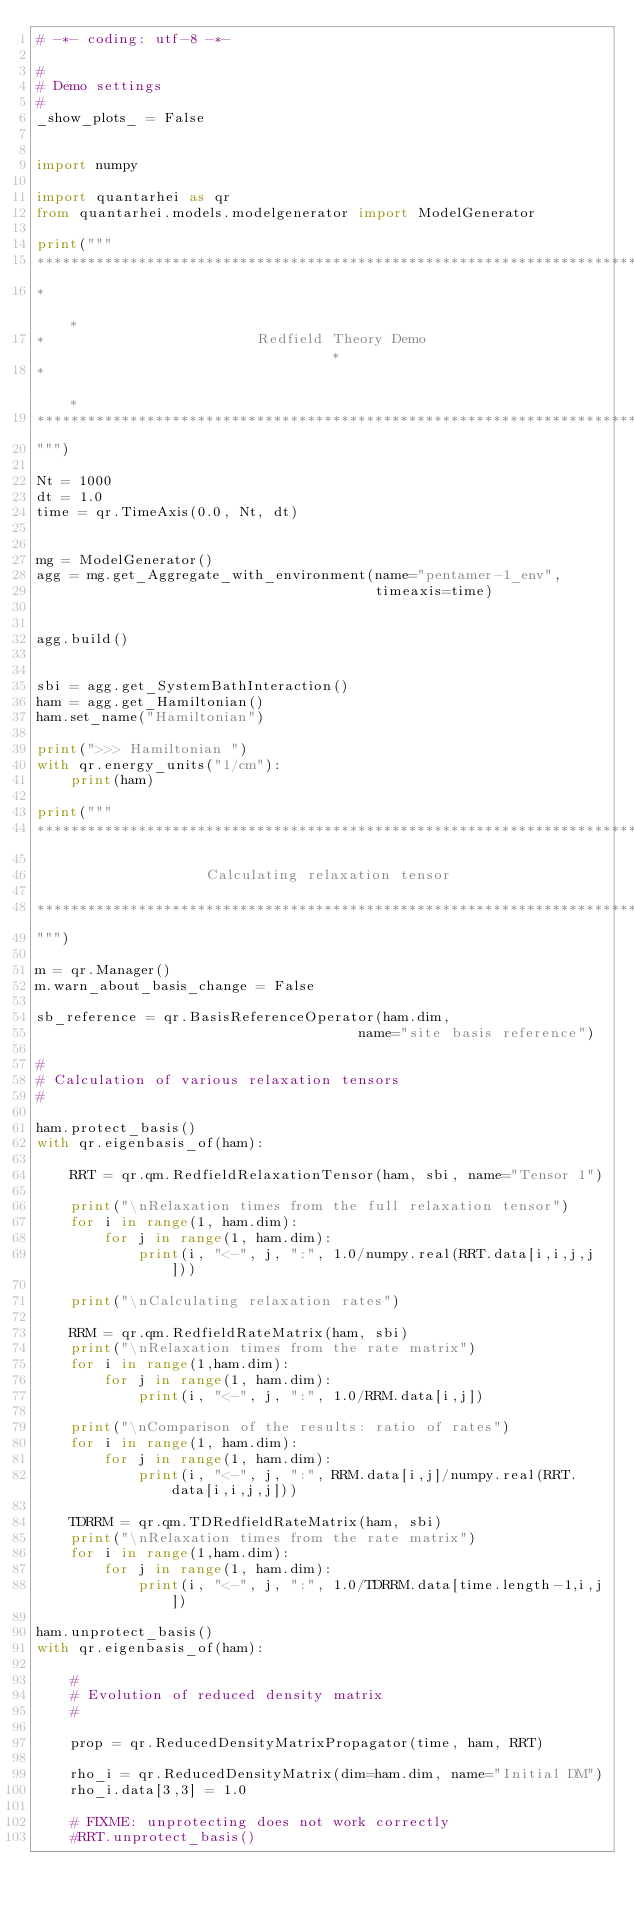Convert code to text. <code><loc_0><loc_0><loc_500><loc_500><_Python_># -*- coding: utf-8 -*-

#
# Demo settings
#
_show_plots_ = False


import numpy

import quantarhei as qr
from quantarhei.models.modelgenerator import ModelGenerator

print("""
*******************************************************************************
*                                                                             *
*                         Redfield Theory Demo                                *
*                                                                             *                  
*******************************************************************************
""")

Nt = 1000
dt = 1.0
time = qr.TimeAxis(0.0, Nt, dt)


mg = ModelGenerator()
agg = mg.get_Aggregate_with_environment(name="pentamer-1_env",
                                        timeaxis=time)


agg.build()


sbi = agg.get_SystemBathInteraction()
ham = agg.get_Hamiltonian()
ham.set_name("Hamiltonian")

print(">>> Hamiltonian ")
with qr.energy_units("1/cm"):
    print(ham)

print("""
*******************************************************************************

                    Calculating relaxation tensor
                  
*******************************************************************************
""")

m = qr.Manager()
m.warn_about_basis_change = False 

sb_reference = qr.BasisReferenceOperator(ham.dim,
                                      name="site basis reference")

#
# Calculation of various relaxation tensors
#

ham.protect_basis()
with qr.eigenbasis_of(ham):
    
    RRT = qr.qm.RedfieldRelaxationTensor(ham, sbi, name="Tensor 1")
    
    print("\nRelaxation times from the full relaxation tensor")
    for i in range(1, ham.dim):
        for j in range(1, ham.dim):
            print(i, "<-", j, ":", 1.0/numpy.real(RRT.data[i,i,j,j]))
        
    print("\nCalculating relaxation rates")
    
    RRM = qr.qm.RedfieldRateMatrix(ham, sbi)
    print("\nRelaxation times from the rate matrix")
    for i in range(1,ham.dim):
        for j in range(1, ham.dim):
            print(i, "<-", j, ":", 1.0/RRM.data[i,j])

    print("\nComparison of the results: ratio of rates")
    for i in range(1, ham.dim):
        for j in range(1, ham.dim):
            print(i, "<-", j, ":", RRM.data[i,j]/numpy.real(RRT.data[i,i,j,j]))

    TDRRM = qr.qm.TDRedfieldRateMatrix(ham, sbi)
    print("\nRelaxation times from the rate matrix")
    for i in range(1,ham.dim):
        for j in range(1, ham.dim):
            print(i, "<-", j, ":", 1.0/TDRRM.data[time.length-1,i,j])

ham.unprotect_basis()
with qr.eigenbasis_of(ham):
    
    #
    # Evolution of reduced density matrix
    #

    prop = qr.ReducedDensityMatrixPropagator(time, ham, RRT)

    rho_i = qr.ReducedDensityMatrix(dim=ham.dim, name="Initial DM")
    rho_i.data[3,3] = 1.0
   
    # FIXME: unprotecting does not work correctly
    #RRT.unprotect_basis()
    </code> 